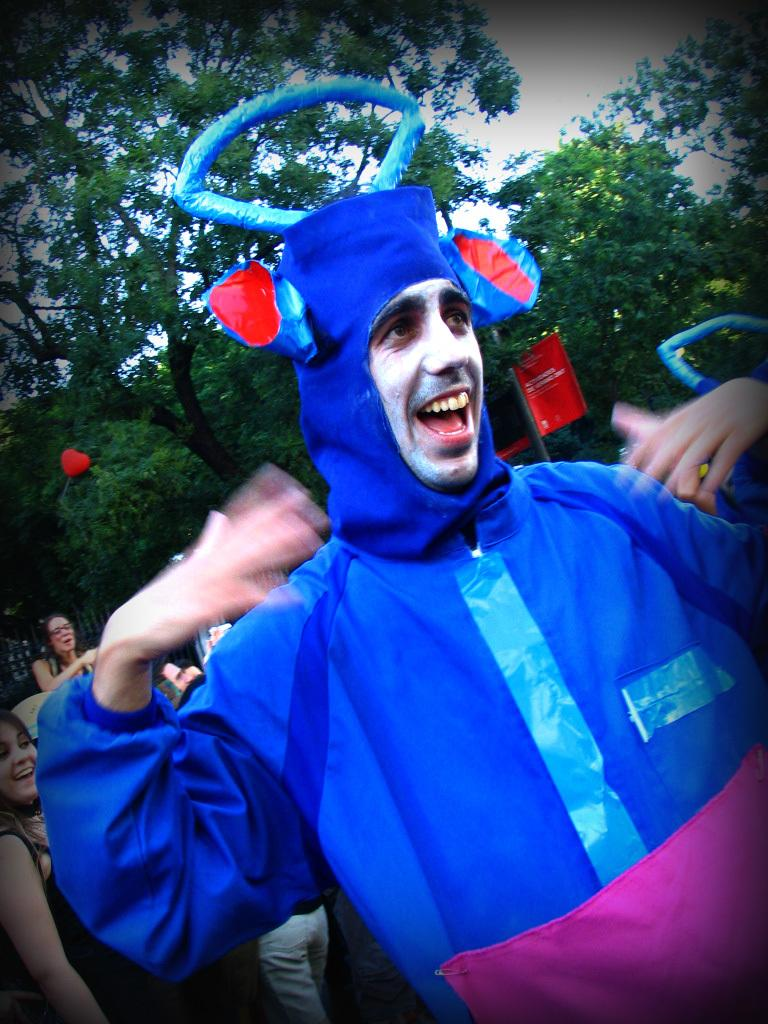Who or what can be seen in the image? There are people in the image. What else is present in the image besides the people? There is an advertising board, trees, and plants in the image. What type of skirt is being worn by the boat in the image? There is no boat present in the image, and therefore no skirt can be associated with it. 